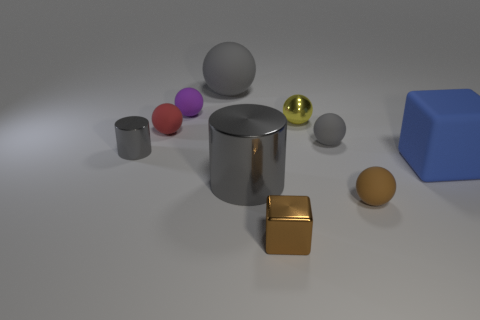Subtract all tiny gray spheres. How many spheres are left? 5 Subtract 2 balls. How many balls are left? 4 Subtract all red spheres. How many spheres are left? 5 Subtract all brown balls. Subtract all brown cylinders. How many balls are left? 5 Subtract all cylinders. How many objects are left? 8 Subtract 1 brown balls. How many objects are left? 9 Subtract all tiny balls. Subtract all small purple balls. How many objects are left? 4 Add 7 blue cubes. How many blue cubes are left? 8 Add 1 yellow metal spheres. How many yellow metal spheres exist? 2 